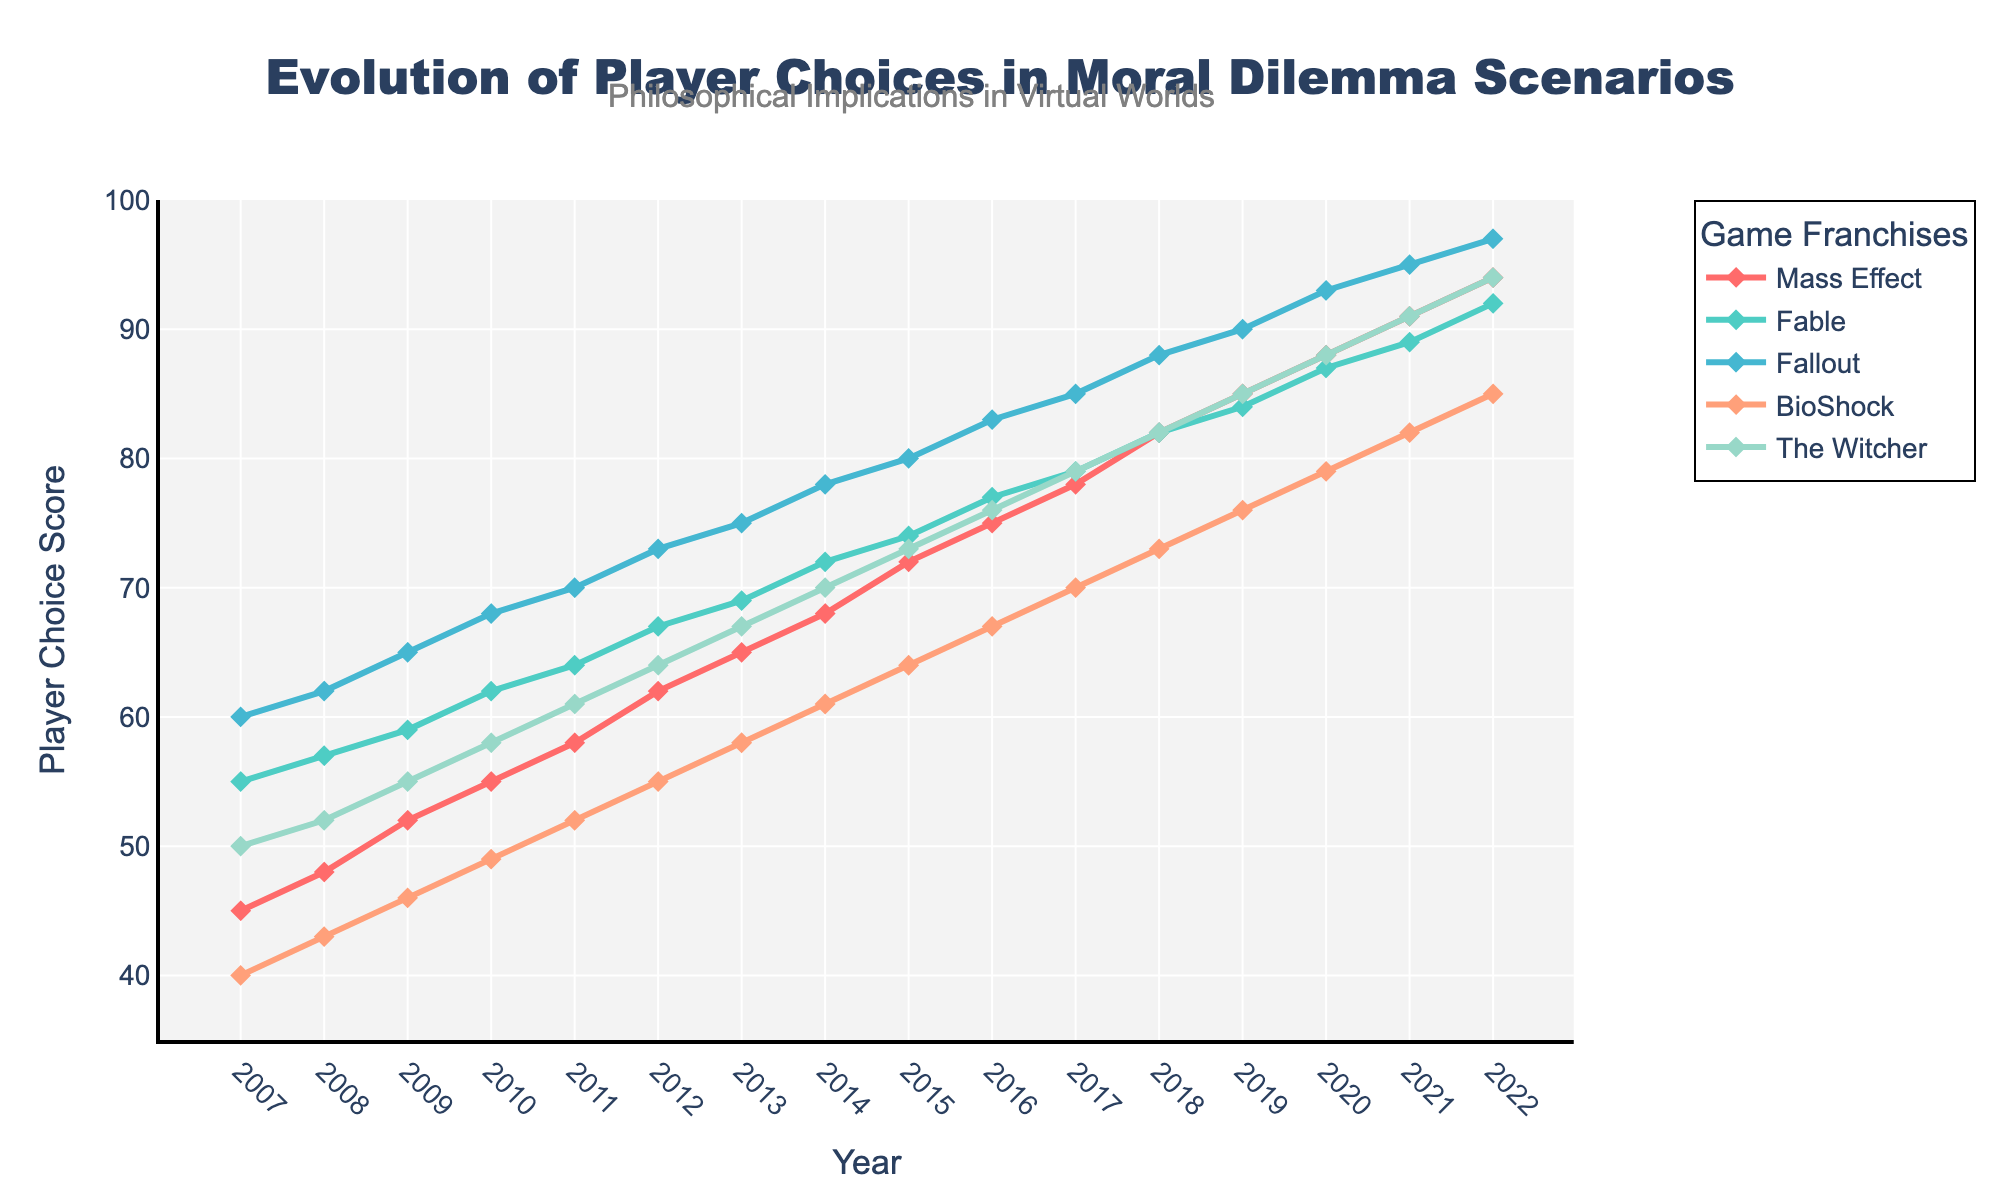What's the game franchise with the highest player choice score in 2022? Check the data points for 2022 and observe which one reaches the highest on the y-axis. The Witcher has the highest point at 94.
Answer: The Witcher How did the player choice score of BioShock evolve between 2011 and 2015? Look at BioShock's score points between 2011 and 2015 and observe the changes. BioShock's scores are 52, 55, 58, 61, 64 in those years, respectively.
Answer: It increased each year Which game had the smallest increase in player choice score from 2007 to 2022? Calculate the difference between the scores for each game between 2007 and 2022 and identify the smallest one. Fable increased by 92-55=37 points, the smallest among all games.
Answer: Fable Compare the trends of Mass Effect and Fallout between 2007 and 2017. Which had a steeper increase? Observe the slope of the lines for Mass Effect and Fallout. Calculate their total increase over the period. Mass Effect went from 45 to 78 (33 points), and Fallout went from 60 to 85 (25 points).
Answer: Mass Effect What's the average player choice score for The Witcher from 2007 to 2022? Sum up all the scores for The Witcher through these years and divide by the number of years. (50 + 52 + 55 + 58 + 61 + 64 + 67 + 70 + 73 + 76 + 79 + 82 + 85 + 88 + 91 + 94) / 16 = 69.5
Answer: 69.5 In which year did Mass Effect see the largest single-year increase in player choice score? Inspect the yearly increases for Mass Effect and find the largest one. From 2007 to 2008, the increase was 48-45=3; from 2008 to 2009, 52-48=4, etc. The largest is from 2021 to 2022: 94-91=3.
Answer: 2022 What is the difference in player choice score between Fallout and BioShock in 2020? Subtract BioShock's score from Fallout's score in 2020. Fallout is 93, BioShock is 79, so the difference is 93-79=14.
Answer: 14 What trend does Fable exhibit over the years? Is it linear, exponential, etc.? Observe the slope and shape of Fable's line over the years. Fable shows a consistent, somewhat linear rise without sudden jumps or drops.
Answer: Linear 